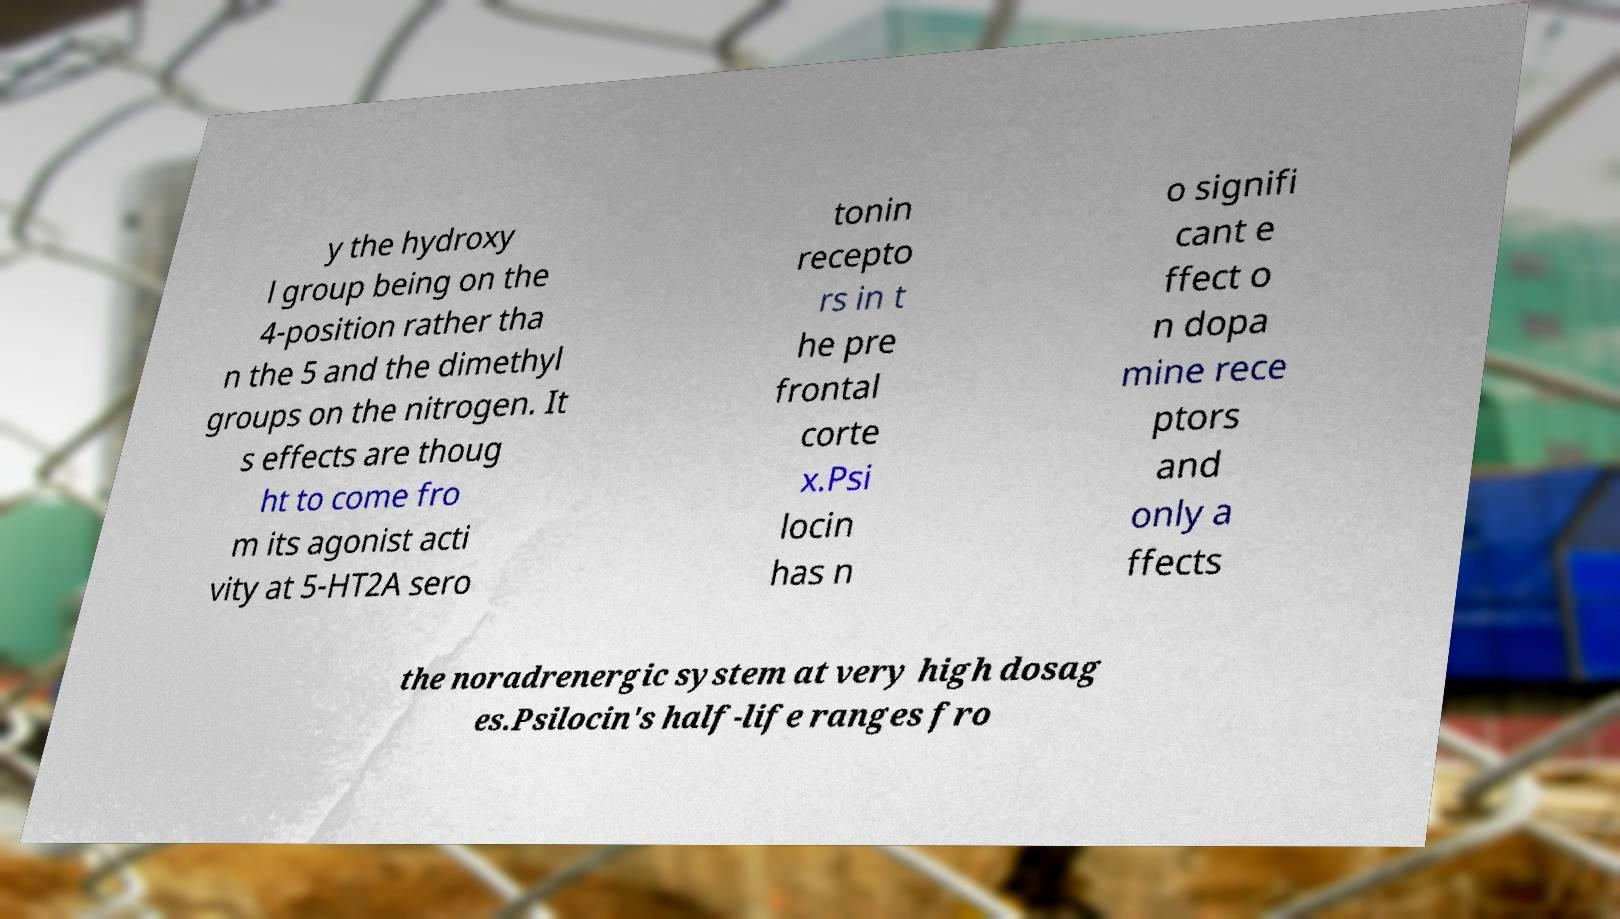There's text embedded in this image that I need extracted. Can you transcribe it verbatim? y the hydroxy l group being on the 4-position rather tha n the 5 and the dimethyl groups on the nitrogen. It s effects are thoug ht to come fro m its agonist acti vity at 5-HT2A sero tonin recepto rs in t he pre frontal corte x.Psi locin has n o signifi cant e ffect o n dopa mine rece ptors and only a ffects the noradrenergic system at very high dosag es.Psilocin's half-life ranges fro 